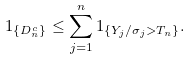<formula> <loc_0><loc_0><loc_500><loc_500>1 _ { \{ D _ { n } ^ { c } \} } \leq \sum _ { j = 1 } ^ { n } 1 _ { \{ Y _ { j } / \sigma _ { j } > T _ { n } \} } .</formula> 